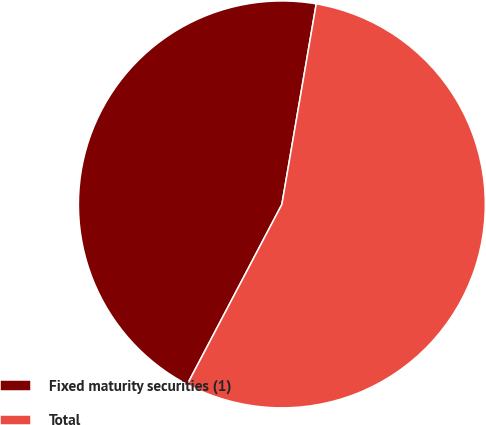Convert chart to OTSL. <chart><loc_0><loc_0><loc_500><loc_500><pie_chart><fcel>Fixed maturity securities (1)<fcel>Total<nl><fcel>45.0%<fcel>55.0%<nl></chart> 